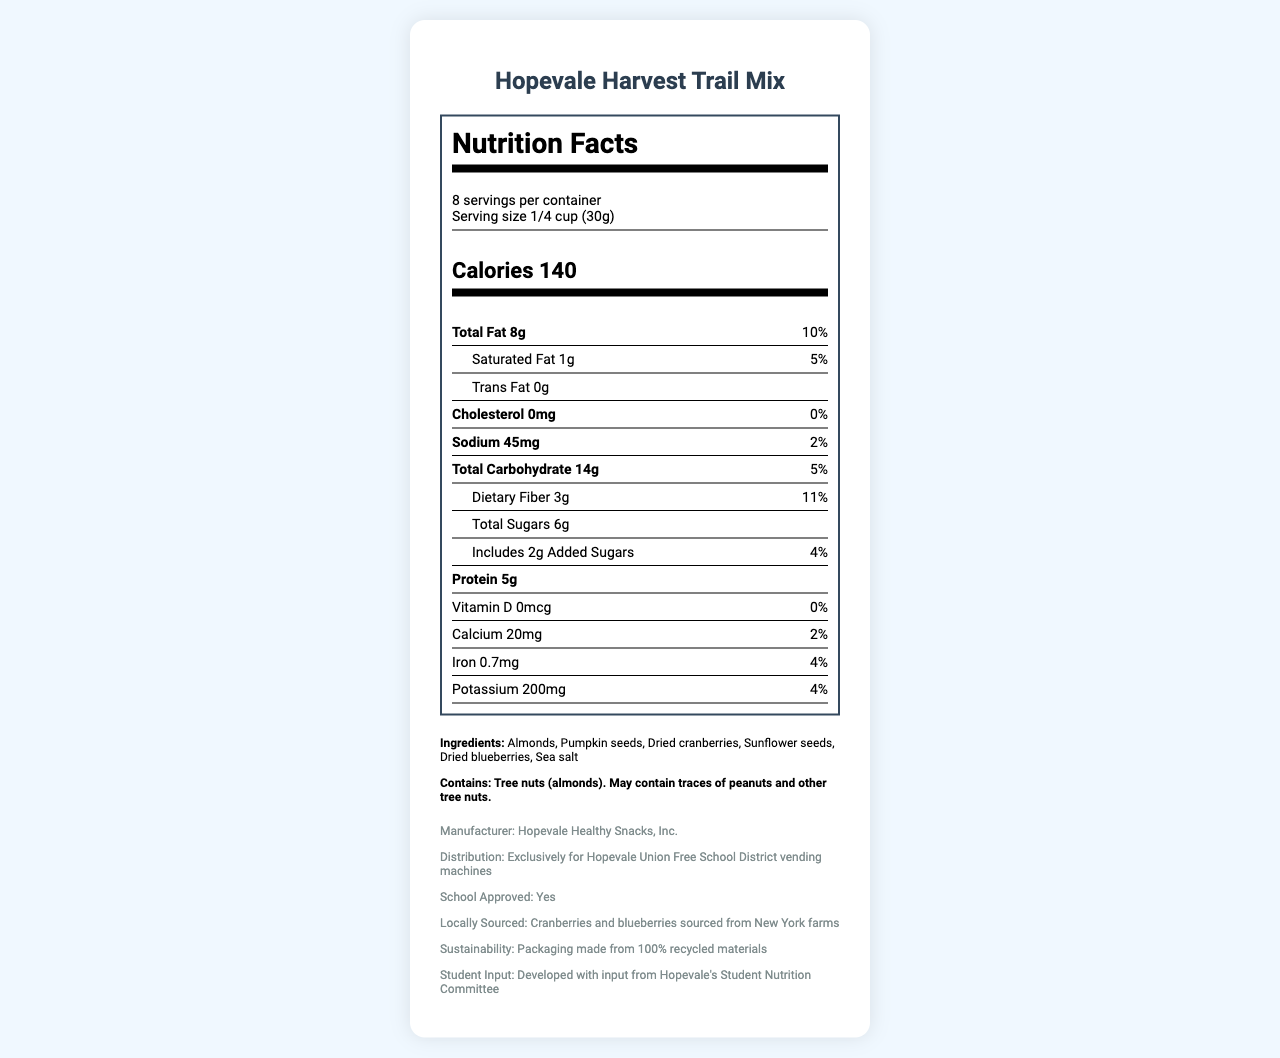what is the serving size of Hopevale Harvest Trail Mix? The serving size is specified directly under "serving size" in the document.
Answer: 1/4 cup (30g) how many servings are in one container? The document lists "8 servings per container" in the serving information section.
Answer: 8 what are the total calories per serving? "Calories 140" is clearly labeled in the calorie information section of the document.
Answer: 140 how much sodium does a serving contain? The sodium content per serving is explicitly stated as 45mg in the nutrient information section.
Answer: 45mg how much dietary fiber is in one serving? The dietary fiber amount per serving is listed as 3g in the nutrient information section.
Answer: 3g what is the percentage daily value of total fat? A. 10% B. 5% C. 2% The document shows the daily value for total fat as 10% right next to the total fat content.
Answer: A. 10% which of these ingredients are in the Hopevale Harvest Trail Mix? I. Almonds II. Peanuts III. Pumpkin seeds IV. Dried blueberries The ingredients listed are: "Almonds, Pumpkin seeds, Dried cranberries, Sunflower seeds, Dried blueberries, Sea salt," but there are no peanuts mentioned.
Answer: I, III, IV does the product contain any tree nuts? The allergen information clearly states that the product contains tree nuts (almonds).
Answer: Yes is the packaging made from recycled materials? The document states in the additional information section that the packaging is made from 100% recycled materials.
Answer: Yes provide a summary of the Hopevale Harvest Trail Mix nutrition facts document. The document contains comprehensive nutritional information for a custom healthy snack introduced by Hopevale’s School District, highlighting its nutritional value, sourcing, and sustainability efforts.
Answer: The document presents detailed nutrition information for Hopevale Harvest Trail Mix, a snack offered in Hopevale’s vending machines. It specifies the serving size, servings per container, and provides a detailed breakdown of calorie content, macronutrients, micronutrients, and ingredients. The product contains tree nuts and is school-approved, locally sourced, and packaged sustainably. The development also involved input from Hopevale's Student Nutrition Committee. how much calcium is in one serving? The amount of calcium per serving is listed as 20mg in the nutrient information section.
Answer: 20mg how many grams of total sugars are there in one serving? The amount of total sugars per serving is listed as 6g in the nutrient information section.
Answer: 6g what is the manufacturer of the Hopevale Harvest Trail Mix? The manufacturer's name is provided in the additional information section.
Answer: Hopevale Healthy Snacks, Inc. is the product approved by the school? The document states that the product is school-approved in the additional information section.
Answer: Yes what is the distribution method for the product? The distribution method is mentioned in the additional information section.
Answer: Exclusively for Hopevale Union Free School District vending machines what is the main source of the dried fruits in the snack? The additional information mentions that cranberries and blueberries are locally sourced from New York farms.
Answer: New York farms what is the exact cholesterol amount per serving? The cholesterol amount is explicitly stated as 0mg in the nutrient information section.
Answer: 0mg did the Student Nutrition Committee have a role in developing this product? The additional information section mentions that the product was developed with input from Hopevale's Student Nutrition Committee.
Answer: Yes what is the nutritional impact if I consume the entire container? The document provides per serving nutritional information but does not detail the effect of consuming multiple servings in a simple summary. To determine the full impact, you'd need to multiply each per-serving nutrient by the number of servings (8).
Answer: Cannot be determined 